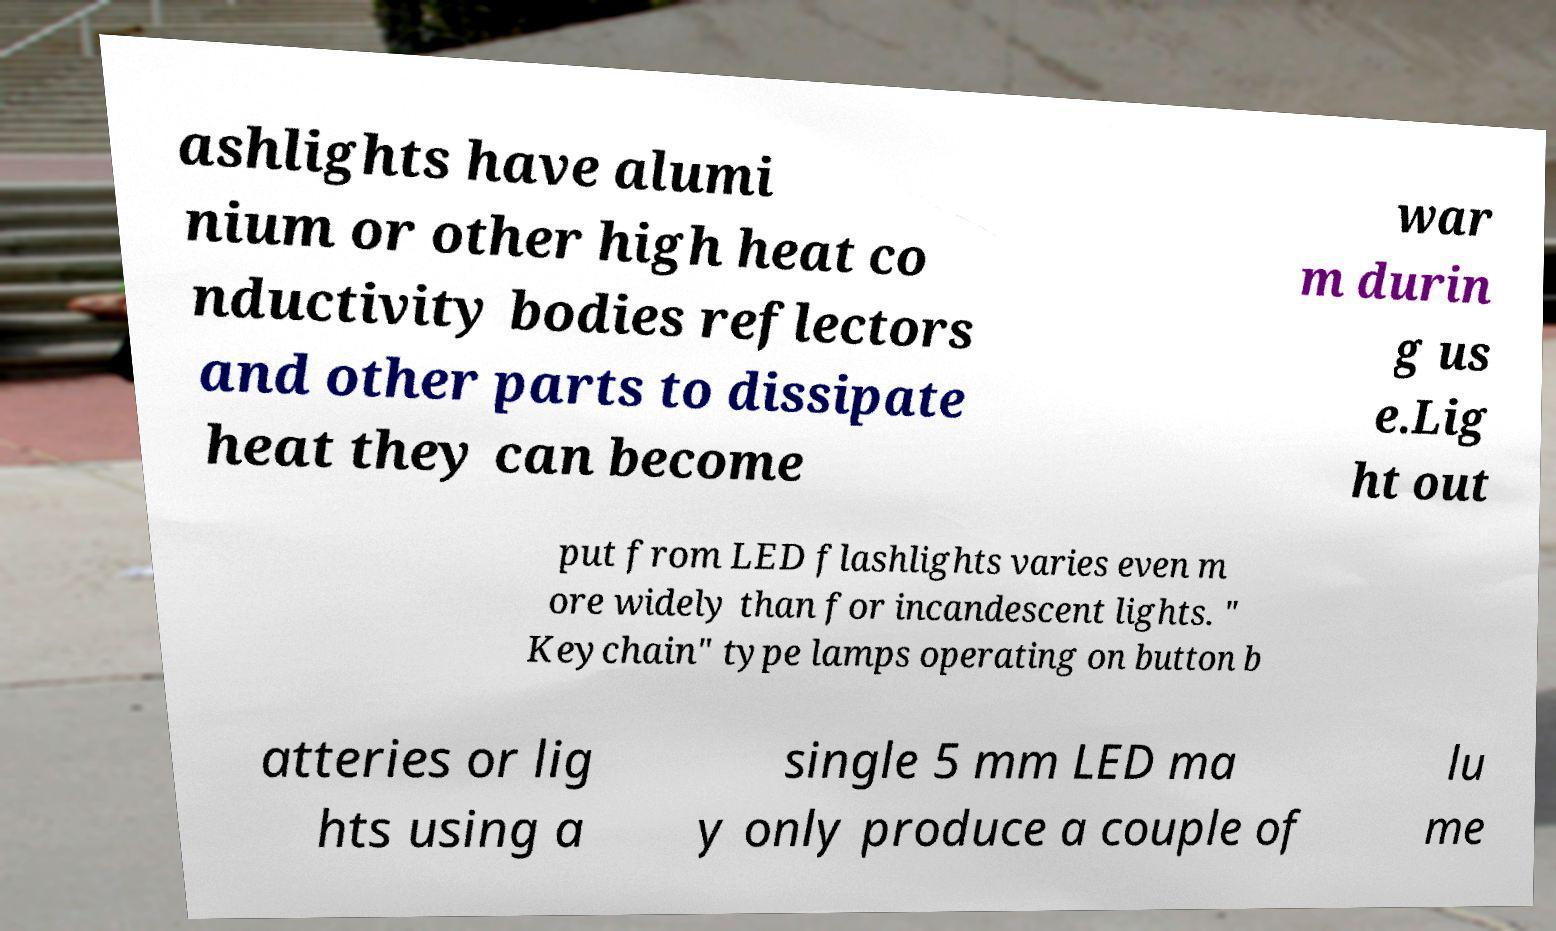Could you assist in decoding the text presented in this image and type it out clearly? ashlights have alumi nium or other high heat co nductivity bodies reflectors and other parts to dissipate heat they can become war m durin g us e.Lig ht out put from LED flashlights varies even m ore widely than for incandescent lights. " Keychain" type lamps operating on button b atteries or lig hts using a single 5 mm LED ma y only produce a couple of lu me 